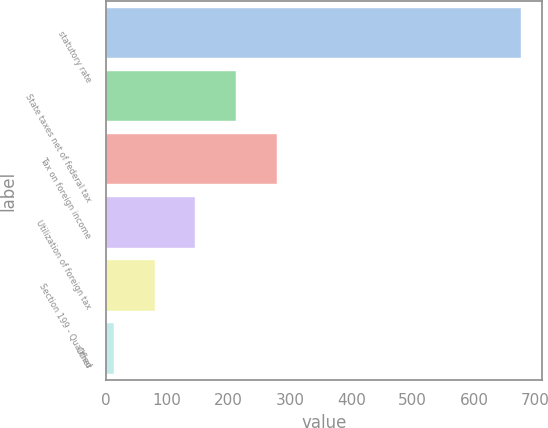Convert chart to OTSL. <chart><loc_0><loc_0><loc_500><loc_500><bar_chart><fcel>statutory rate<fcel>State taxes net of federal tax<fcel>Tax on foreign income<fcel>Utilization of foreign tax<fcel>Section 199 - Qualified<fcel>Other<nl><fcel>676.5<fcel>212.26<fcel>278.58<fcel>145.94<fcel>79.62<fcel>13.3<nl></chart> 